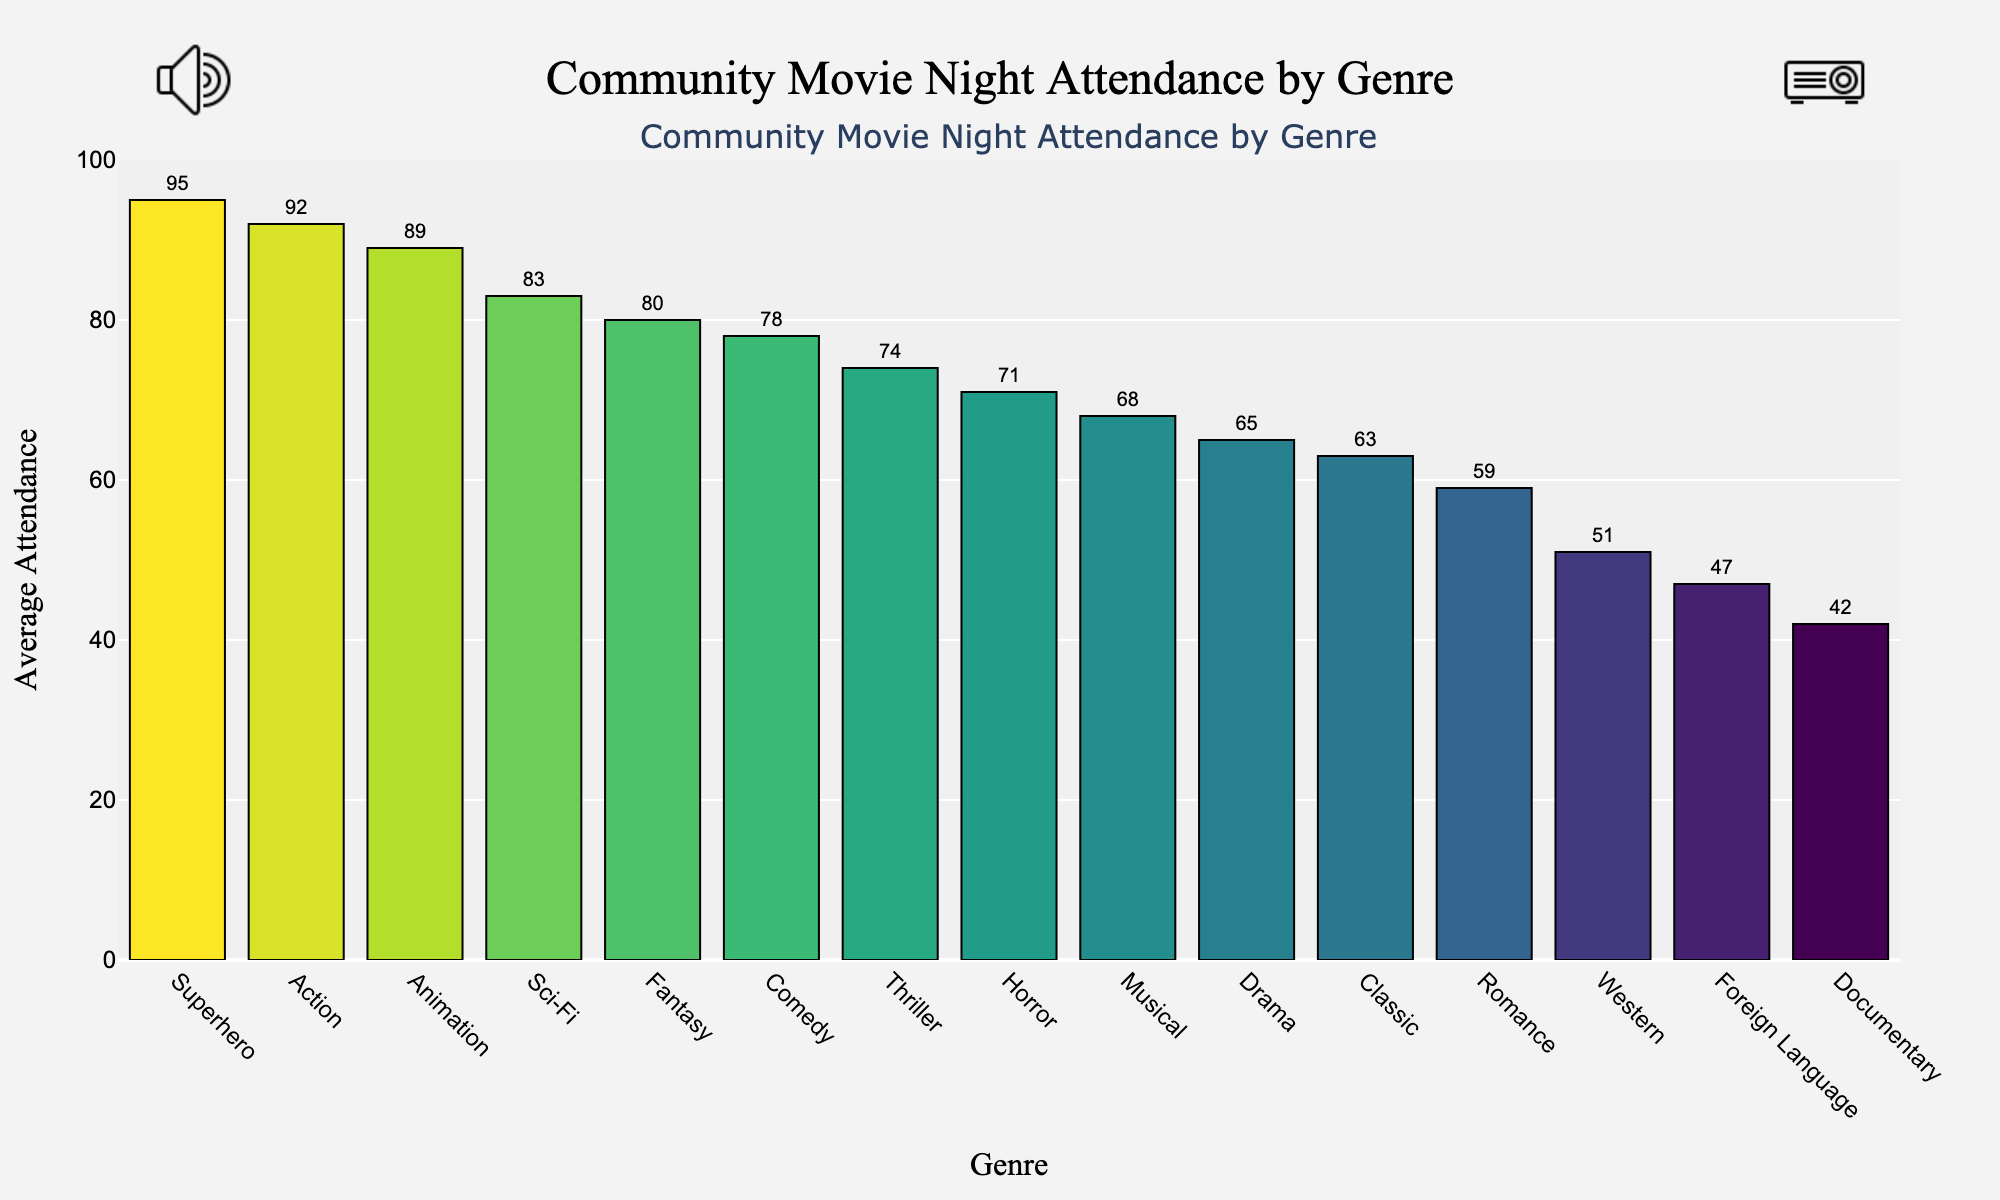Which genre has the highest average attendance? The bar representing Superhero is the tallest, indicating it has the highest average attendance.
Answer: Superhero Which genre has the lowest average attendance? The bar representing Documentary is the shortest, indicating it has the lowest average attendance.
Answer: Documentary What is the difference in average attendance between Action and Romance genres? According to the bars, Action has an average attendance of 92 and Romance has 59. The difference is 92 - 59 = 33.
Answer: 33 Which genres have an average attendance greater than 80 but less than 90? The bars for Sci-Fi, Animation, and Fantasy fall within this range.
Answer: Sci-Fi, Animation, Fantasy What is the total average attendance for Comedy, Action, and Drama combined? The average attendances for these genres are 78, 92, and 65 respectively. Summing them up: 78 + 92 + 65 = 235.
Answer: 235 How does the average attendance for Animation compare with Comedy? The bar for Animation is taller than the bar for Comedy, indicating that Animation has a higher average attendance.
Answer: Animation has higher attendance Are there any genres with an average attendance close to 50? The bars for Western and Foreign Language are around this range, with average attendances of 51 and 47 respectively.
Answer: Western, Foreign Language Which genre shows a slightly higher attendance, Thriller or Horror? The bar for Thriller is slightly taller than the bar for Horror, indicating a higher average attendance.
Answer: Thriller What is the visual attribute used to highlight the differences in attendance? The height of the bars and the color intensity in the plot are used to distinguish the average attendances.
Answer: Height and color intensity 